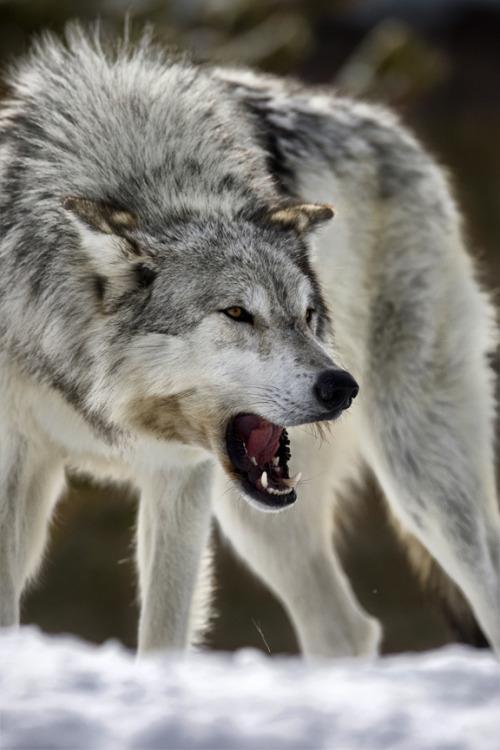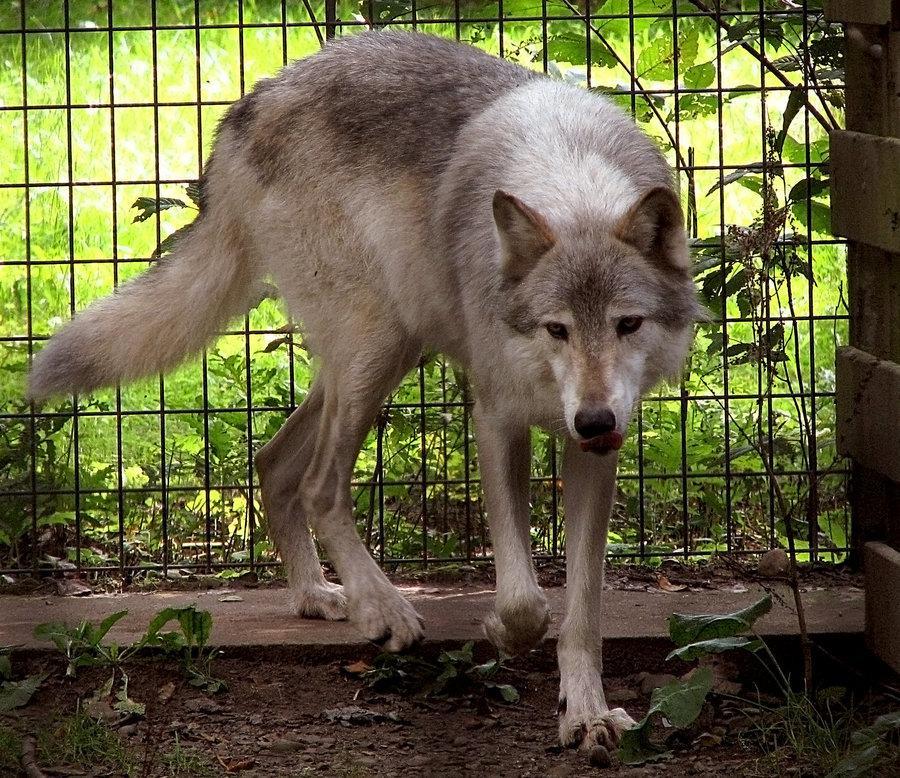The first image is the image on the left, the second image is the image on the right. Examine the images to the left and right. Is the description "There is a fence behind the animal in the image on the left." accurate? Answer yes or no. No. 